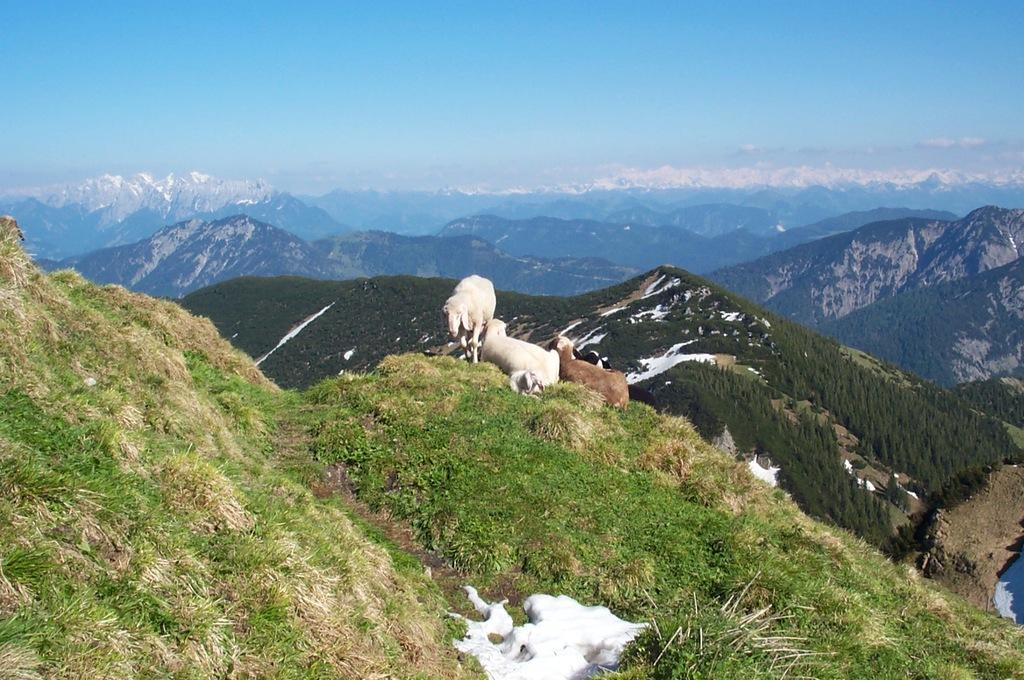How many sheep are in the image? There are three sheep in the image. What is the sheep standing on? The sheep are on the grass. What can be seen in the background of the image? There are hills and mountains in the background of the image, as well as the sky. What type of reward is the sheep holding in the middle of the image? There is no reward present in the image, and the sheep are not holding anything. What is the sheep using to quiver in the image? There is no quivering action or object present in the image involving the sheep. 